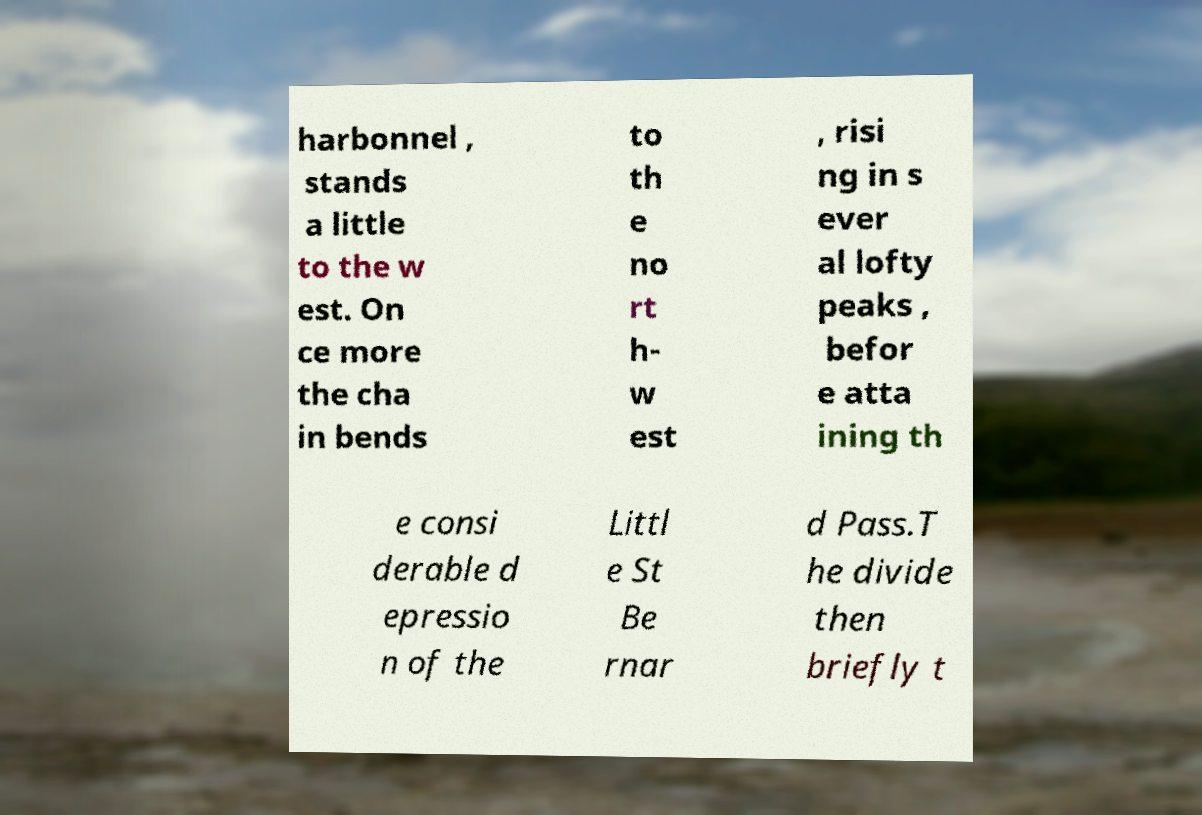Can you read and provide the text displayed in the image?This photo seems to have some interesting text. Can you extract and type it out for me? harbonnel , stands a little to the w est. On ce more the cha in bends to th e no rt h- w est , risi ng in s ever al lofty peaks , befor e atta ining th e consi derable d epressio n of the Littl e St Be rnar d Pass.T he divide then briefly t 